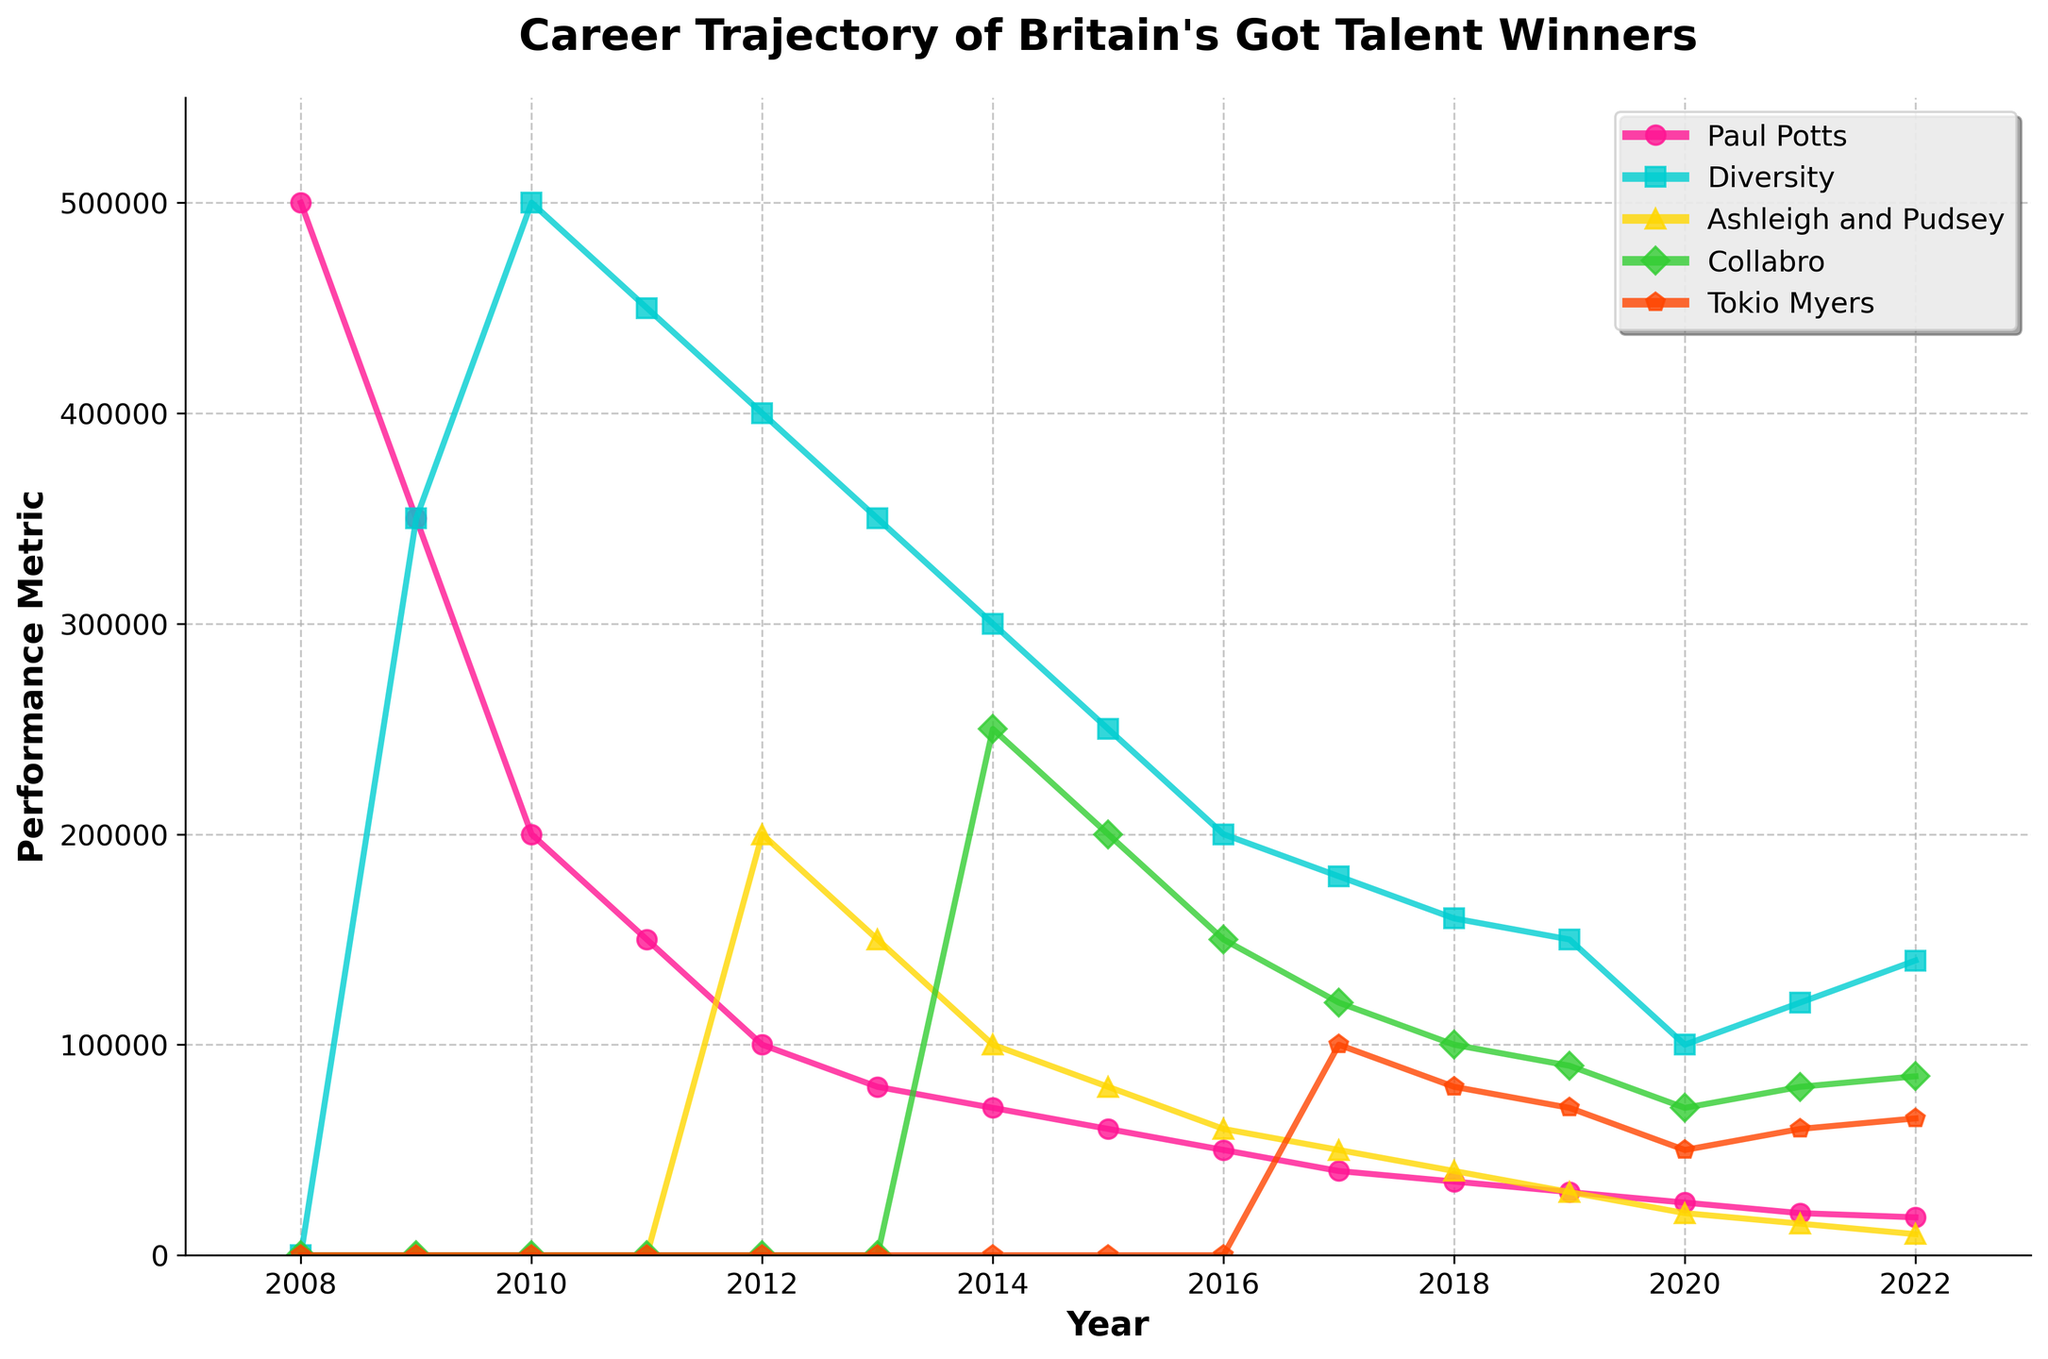How did the performance trajectory of Ashleigh and Pudsey change over the years? Ashleigh and Pudsey appeared on the chart starting in 2012. Their performance bookings started at 200,000 in 2012, peaking at that entry point. From there, their bookings dropped to 150,000 in 2013, then continued to decrease to 10,000 by 2022. The overall trend shows a steady decline.
Answer: It steadily declined Which act had the highest peak performance bookings? In 2010, Diversity reached their peak with 500,000 performance bookings or album sales. Other acts never reached this level of bookings in any year.
Answer: Diversity What was the percentage drop in performance bookings for Paul Potts from 2008 to 2010? Paul Potts had 500,000 bookings in 2008 and 200,000 in 2010. The drop is 300,000. The percentage drop is calculated as (300,000/500,000) * 100 = 60%.
Answer: 60% Between 2017 and 2018, which act showed a steeper decline in bookings, Diversity or Ashleigh and Pudsey? Diversity dropped from 180,000 in 2017 to 160,000 in 2018 for a decrease of 20,000. Ashleigh and Pudsey dropped from 50,000 to 40,000 for a decrease of 10,000. Therefore, Diversity showed a steeper decline.
Answer: Diversity What visual pattern can be observed comparing the trajectories of Collabro and Tokio Myers from 2017 onwards? Both Collabro and Tokio Myers show a similar pattern of steady decline. Collabro starts at 120,000 in 2017 and ends at 85,000 in 2022, while Tokio Myers begins at 100,000 in 2017 and drops to 65,000 by 2022. Their trajectories follow a roughly parallel downward slope.
Answer: Steady decline, similar trajectories How many years did Paul Potts continue to have more bookings than Diversity after Diversity appeared in 2009? After Diversity appeared in 2009, Paul Potts had more bookings in 2009. Therefore, Paul Potts had more bookings than Diversity only for one year following Diversity's appearance.
Answer: 1 year Which act maintained the most consistent performance bookings over the years? Ashleigh and Pudsey’s bookings show less dramatic changes compared to others. They decline moderately, with no sudden spikes or drops. Despite an overall downward trend, their bookings from 2017 to 2022 gradually decrease from 50,000 to 10,000.
Answer: Ashleigh and Pudsey 